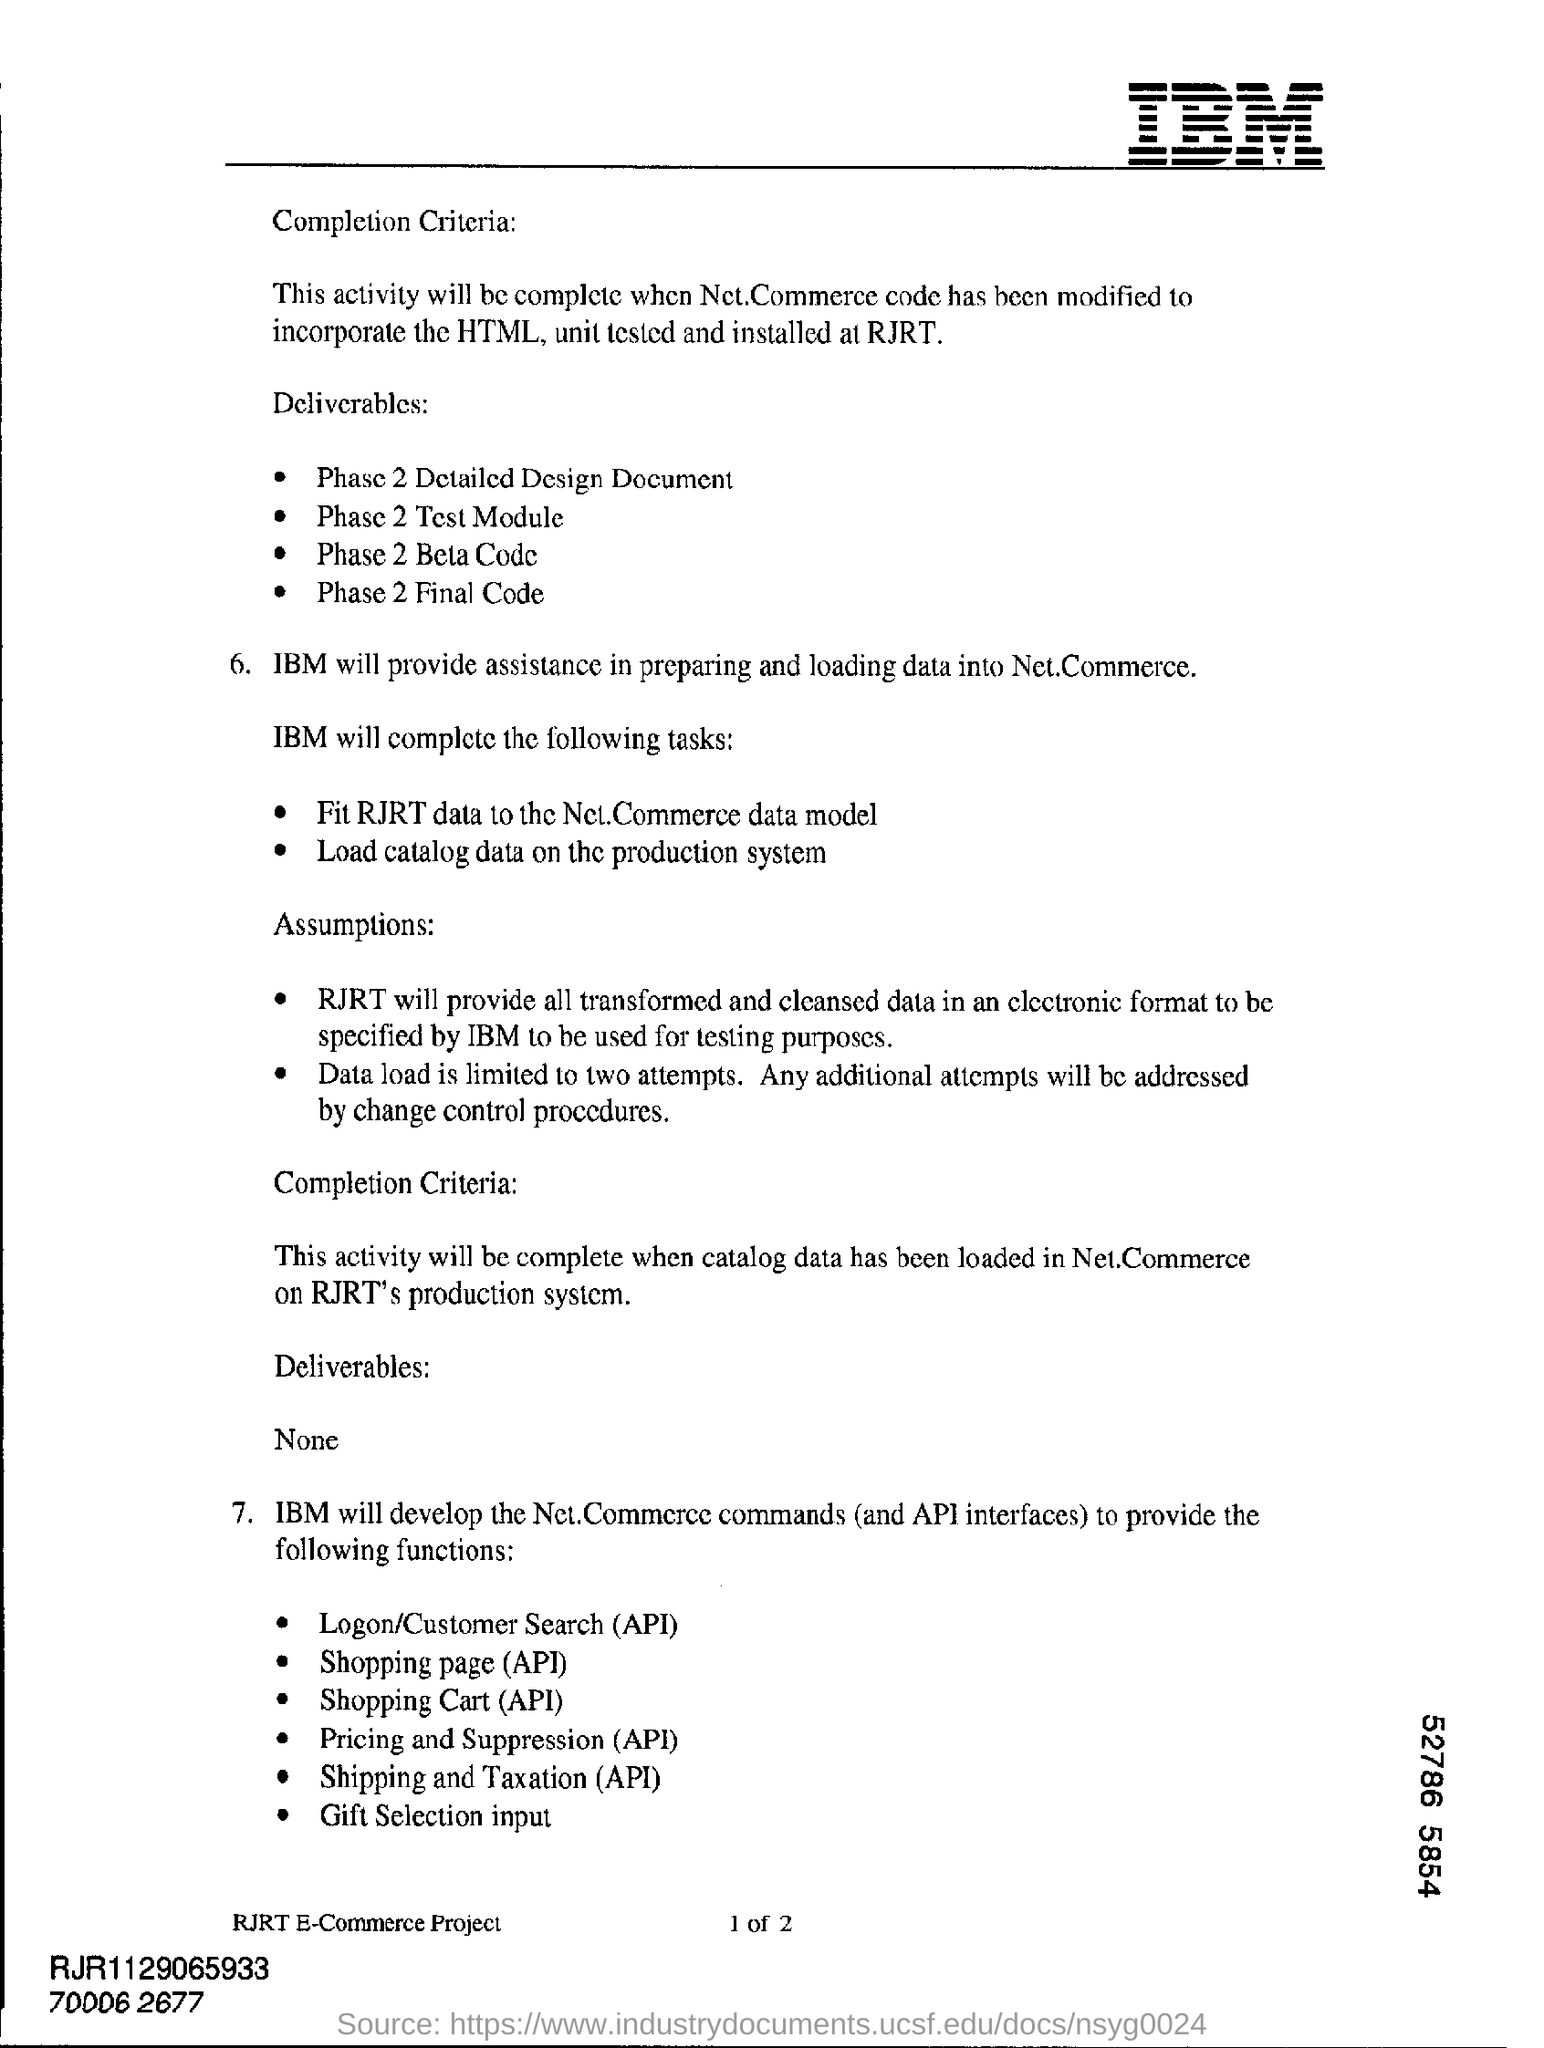Draw attention to some important aspects in this diagram. The catalog data should be loaded on the production system. The heading located at the top right of the page is "IBM. The number of attempts allowed for data loading is two. 